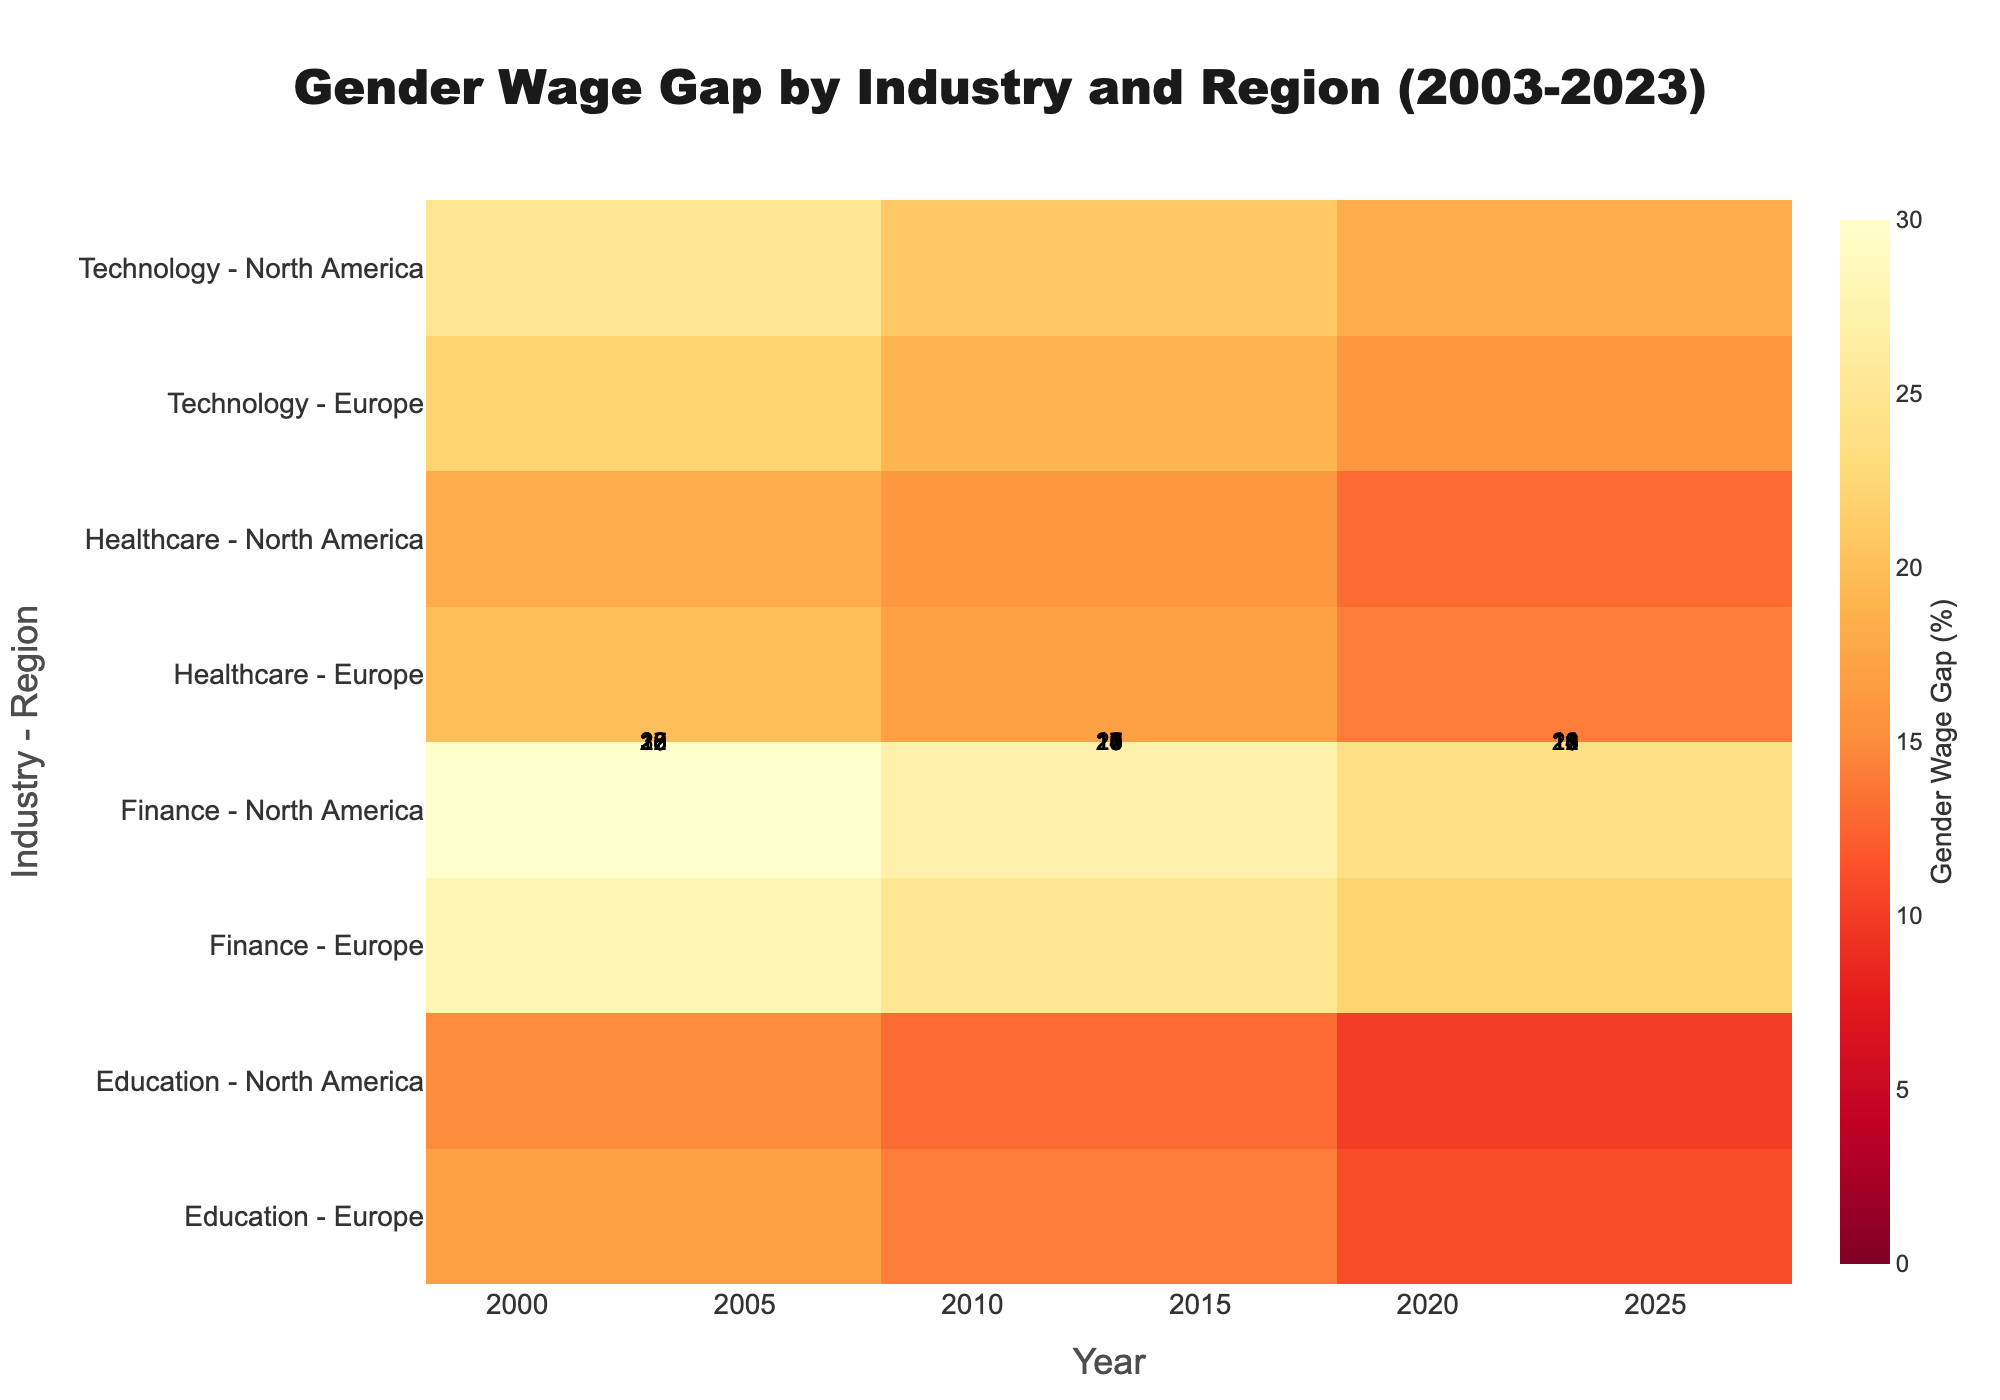How has the gender wage gap in the Finance industry in North America changed from 2003 to 2023? In the Finance industry in North America, the gender wage gap was 30% in 2003, 27% in 2013, and 24% in 2023. To find the change, we subtract the 2023 value from the 2003 value: 30% - 24% = 6%. Thus, the gender wage gap has decreased by 6 percentage points over these 20 years.
Answer: Decreased by 6 percentage points Which industry had the smallest gender wage gap in Europe in 2023? To answer this, look at the 2023 values for each industry in Europe. The values are Technology (16%), Healthcare (14%), Finance (22%), and Education (11%). The smallest value is for Education at 11%.
Answer: Education In which year was the gender wage gap in North America's Healthcare industry the greatest? Look at the gender wage gap values for North America's Healthcare industry across the years. The values are 18% (2003), 16% (2013), and 13% (2023). The greatest value is 18% in the year 2003.
Answer: 2003 Across all years, what is the average gender wage gap in the Technology industry in Europe? The values for the Technology industry in Europe are 22% (2003), 19% (2013), and 16% (2023). To find the average, add these values and divide by the number of years: (22 + 19 + 16) / 3 = 57 / 3 = 19%.
Answer: 19% Compare the gender wage gap trends between the Technology industry in North America and Europe from 2003 to 2023. Which region saw a greater decrease? In North America, the gap decreased from 25% to 18%: 25% - 18% = 7 percentage points. In Europe, the gap decreased from 22% to 16%: 22% - 16% = 6 percentage points. North America saw a greater decrease by 1 percentage point.
Answer: North America What is the difference in the gender wage gap between the Education and Finance industries in Europe in 2023? Look at the 2023 values for Education (11%) and Finance (22%) in Europe. The difference is calculated as 22% - 11% = 11 percentage points.
Answer: 11 percentage points Which industry in North America had the smallest decrease in gender wage gap from 2003 to 2023? Calculate decreases for each industry: Technology (25% to 18% = 7%), Healthcare (18% to 13% = 5%), Finance (30% to 24% = 6%), Education (15% to 10% = 5%). The smallest decrease is in Healthcare and Education, both with a decrease of 5 percentage points.
Answer: Healthcare and Education What was the gender wage gap in Europe's Healthcare industry in 2013? Locate the value for Healthcare in Europe in 2013. The gender wage gap was 17%.
Answer: 17% Which industry-region combination had the highest gender wage gap in 2013? Look at all industry-region combinations for 2013. The highest value is for North America's Finance industry with a gap of 27%.
Answer: Finance in North America By how many percentage points did the gender wage gap in the Education industry in North America decrease from 2003 to 2023? The values are 15% (2003) and 10% (2023). The decrease is calculated as 15% - 10% = 5 percentage points.
Answer: 5 percentage points 